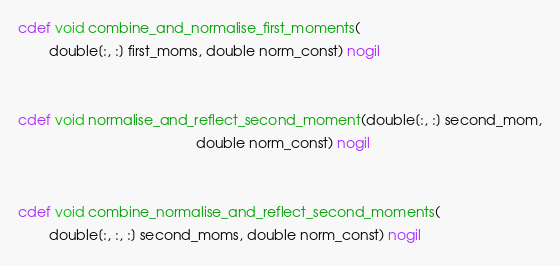<code> <loc_0><loc_0><loc_500><loc_500><_Cython_>cdef void combine_and_normalise_first_moments(
        double[:, :] first_moms, double norm_const) nogil


cdef void normalise_and_reflect_second_moment(double[:, :] second_mom,
                                              double norm_const) nogil


cdef void combine_normalise_and_reflect_second_moments(
        double[:, :, :] second_moms, double norm_const) nogil
</code> 